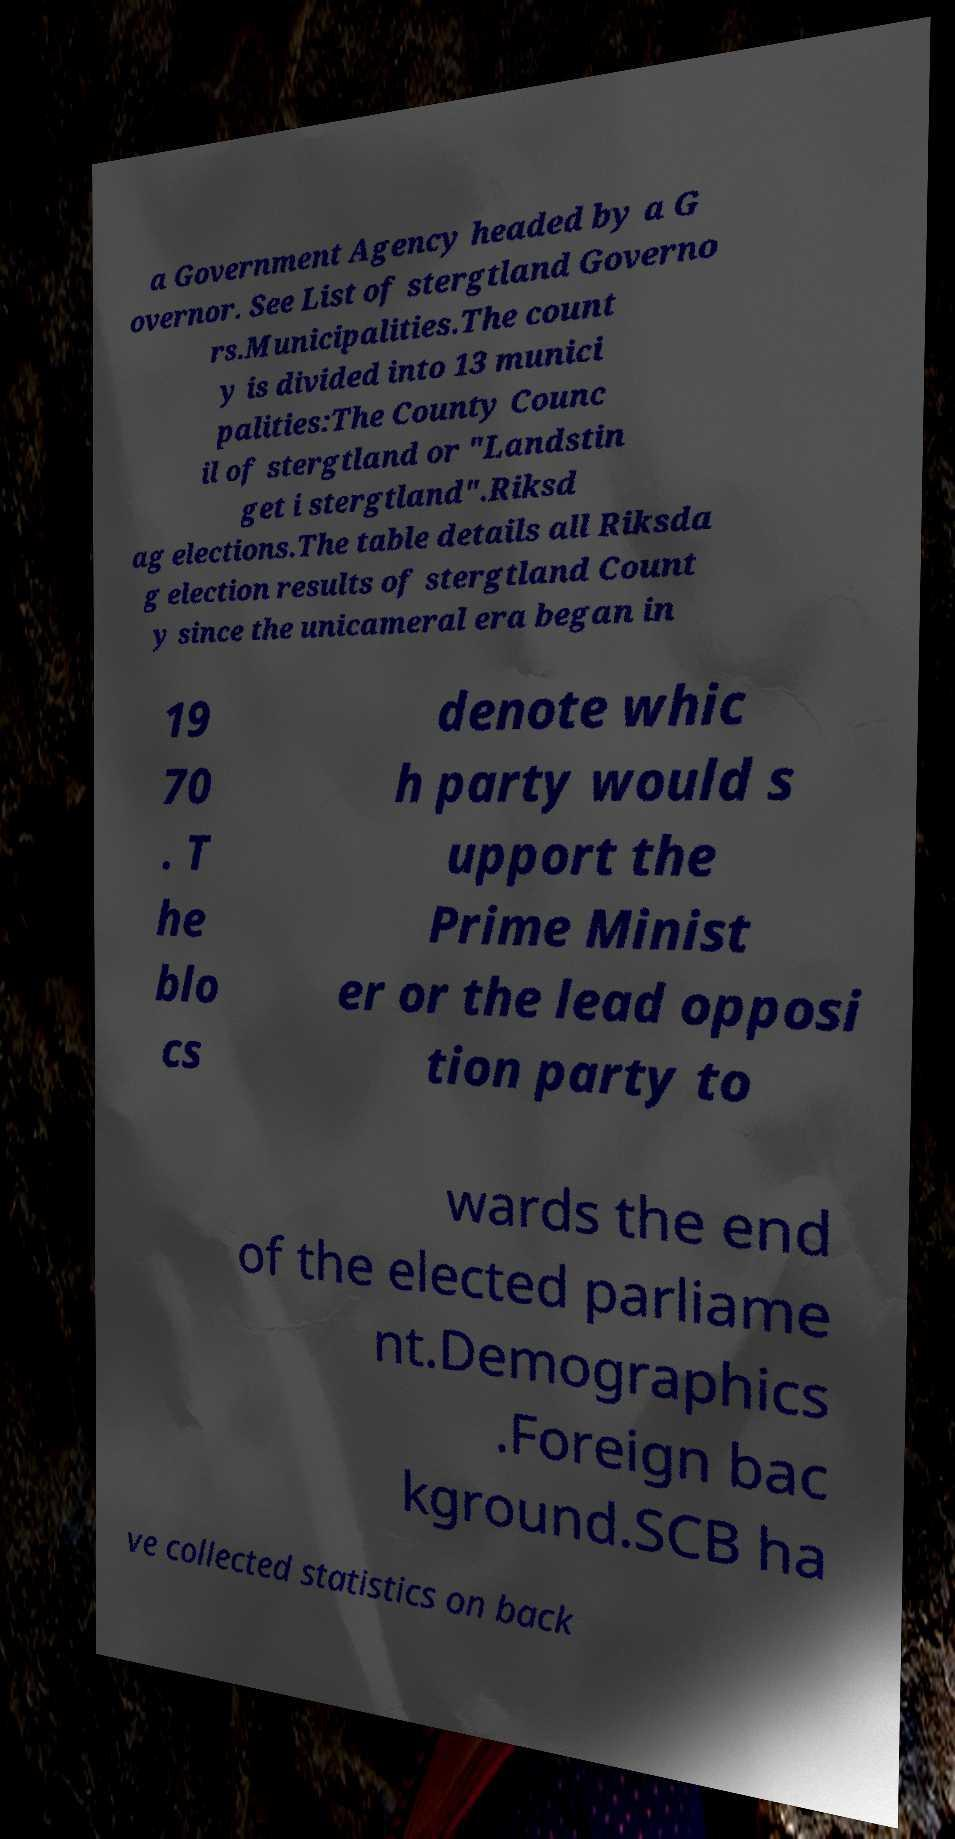For documentation purposes, I need the text within this image transcribed. Could you provide that? a Government Agency headed by a G overnor. See List of stergtland Governo rs.Municipalities.The count y is divided into 13 munici palities:The County Counc il of stergtland or "Landstin get i stergtland".Riksd ag elections.The table details all Riksda g election results of stergtland Count y since the unicameral era began in 19 70 . T he blo cs denote whic h party would s upport the Prime Minist er or the lead opposi tion party to wards the end of the elected parliame nt.Demographics .Foreign bac kground.SCB ha ve collected statistics on back 